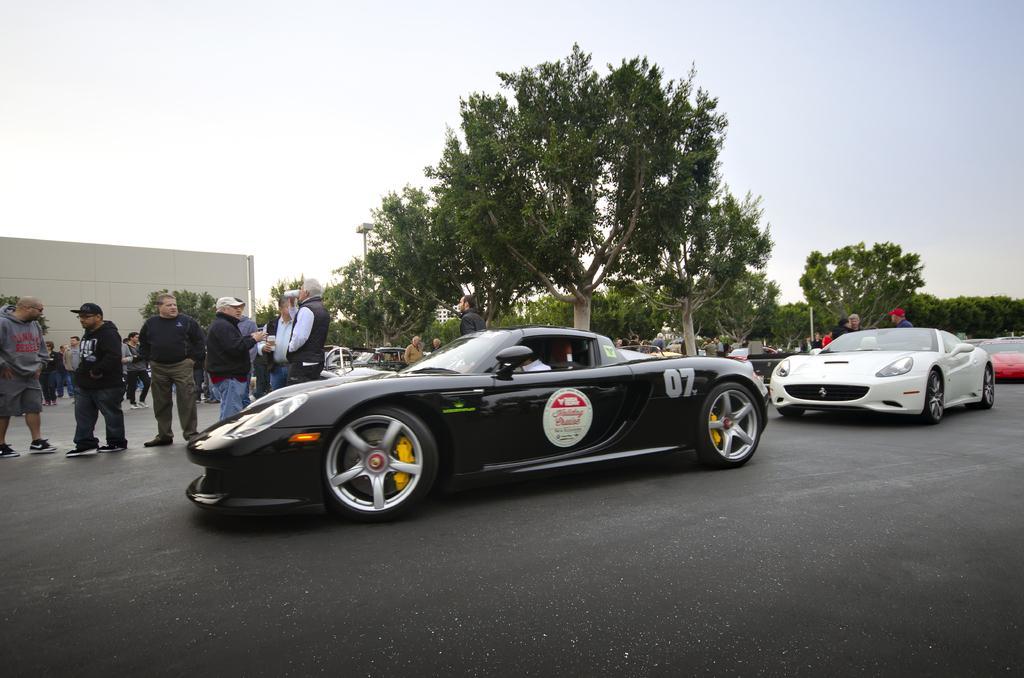Can you describe this image briefly? In this picture we can see few vehicles on the road, beside to the vehicles we can find group of people and trees, in the background we can see few poles and a building. 